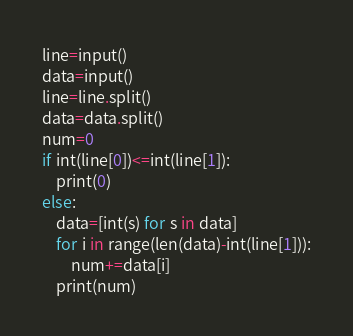Convert code to text. <code><loc_0><loc_0><loc_500><loc_500><_Python_>line=input()
data=input()
line=line.split()
data=data.split()
num=0
if int(line[0])<=int(line[1]):
    print(0)
else:
    data=[int(s) for s in data]
    for i in range(len(data)-int(line[1])):
        num+=data[i]
    print(num)</code> 